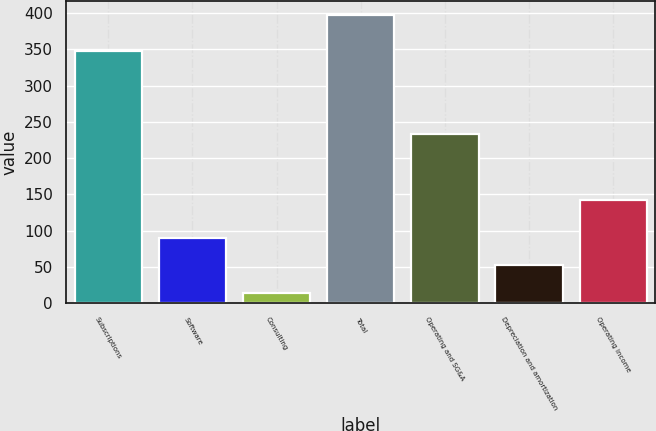Convert chart to OTSL. <chart><loc_0><loc_0><loc_500><loc_500><bar_chart><fcel>Subscriptions<fcel>Software<fcel>Consulting<fcel>Total<fcel>Operating and SG&A<fcel>Depreciation and amortization<fcel>Operating income<nl><fcel>347.5<fcel>90.26<fcel>13.5<fcel>397.3<fcel>232.6<fcel>51.88<fcel>142.5<nl></chart> 